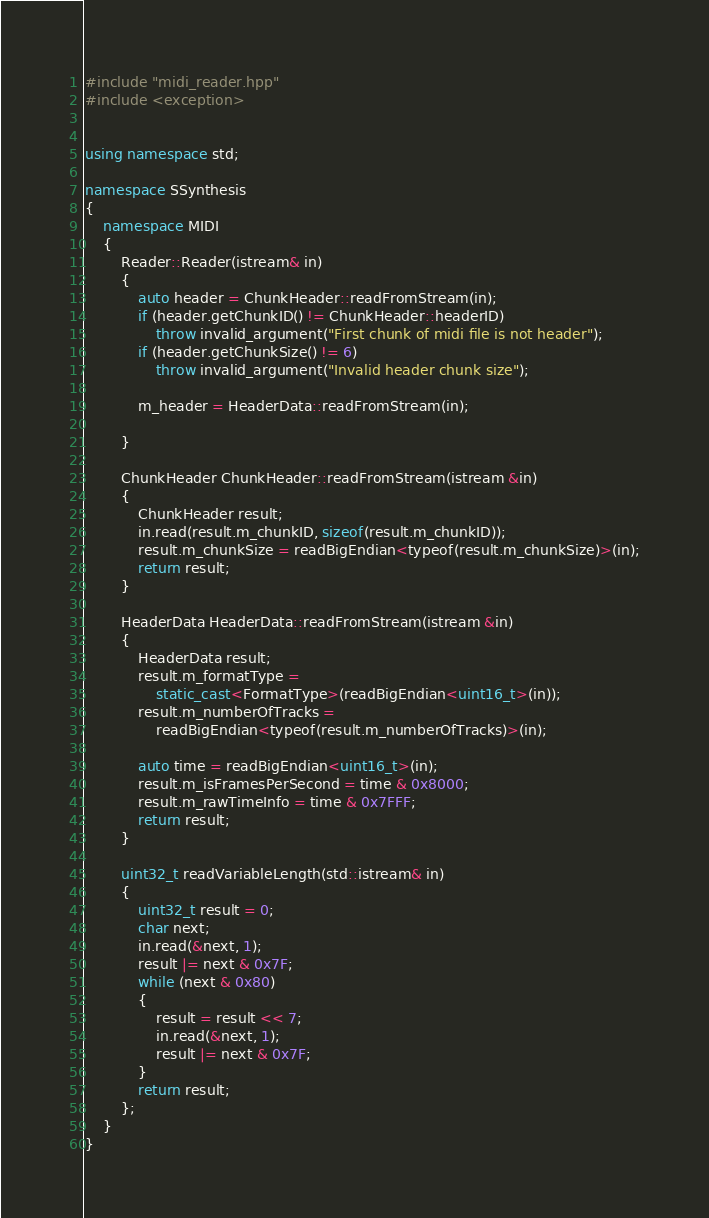Convert code to text. <code><loc_0><loc_0><loc_500><loc_500><_C++_>#include "midi_reader.hpp"
#include <exception>


using namespace std;

namespace SSynthesis
{
    namespace MIDI
    {
        Reader::Reader(istream& in)
        {
            auto header = ChunkHeader::readFromStream(in);
            if (header.getChunkID() != ChunkHeader::headerID)
                throw invalid_argument("First chunk of midi file is not header");
            if (header.getChunkSize() != 6)
                throw invalid_argument("Invalid header chunk size");

            m_header = HeaderData::readFromStream(in);
           
        }

        ChunkHeader ChunkHeader::readFromStream(istream &in)
        {
            ChunkHeader result;
            in.read(result.m_chunkID, sizeof(result.m_chunkID));
            result.m_chunkSize = readBigEndian<typeof(result.m_chunkSize)>(in);
            return result;
        }

        HeaderData HeaderData::readFromStream(istream &in)
        {
            HeaderData result;
            result.m_formatType =
                static_cast<FormatType>(readBigEndian<uint16_t>(in));
            result.m_numberOfTracks =
                readBigEndian<typeof(result.m_numberOfTracks)>(in);

            auto time = readBigEndian<uint16_t>(in);
            result.m_isFramesPerSecond = time & 0x8000;
            result.m_rawTimeInfo = time & 0x7FFF;
            return result;
        }

        uint32_t readVariableLength(std::istream& in)
        {
            uint32_t result = 0;
            char next;
            in.read(&next, 1);
            result |= next & 0x7F;
            while (next & 0x80)
            {
                result = result << 7;
                in.read(&next, 1);
                result |= next & 0x7F;
            }
            return result;
        };
    }
}
</code> 